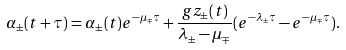Convert formula to latex. <formula><loc_0><loc_0><loc_500><loc_500>\alpha _ { \pm } ( t + \tau ) = \alpha _ { \pm } ( t ) e ^ { - \mu _ { \mp } \tau } + \frac { g z _ { \pm } ( t ) } { \lambda _ { \pm } - \mu _ { \mp } } ( e ^ { - \lambda _ { \pm } \tau } - e ^ { - \mu _ { \mp } \tau } ) .</formula> 